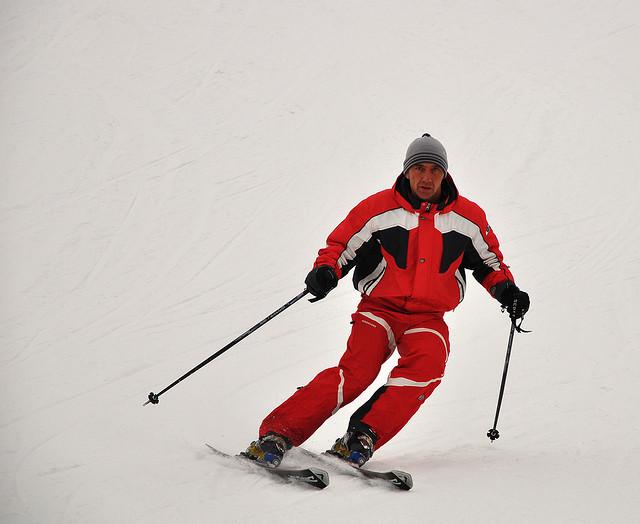Is this an adult or child?
Be succinct. Adult. What color is his jacket?
Give a very brief answer. Red. Is this his first time skiing?
Write a very short answer. No. Is the man's head warm?
Give a very brief answer. Yes. What is the man wearing?
Quick response, please. Snowsuit. 